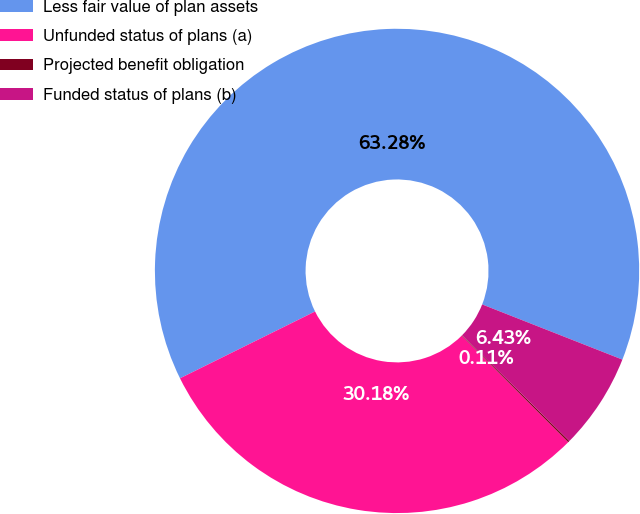Convert chart to OTSL. <chart><loc_0><loc_0><loc_500><loc_500><pie_chart><fcel>Less fair value of plan assets<fcel>Unfunded status of plans (a)<fcel>Projected benefit obligation<fcel>Funded status of plans (b)<nl><fcel>63.28%<fcel>30.18%<fcel>0.11%<fcel>6.43%<nl></chart> 